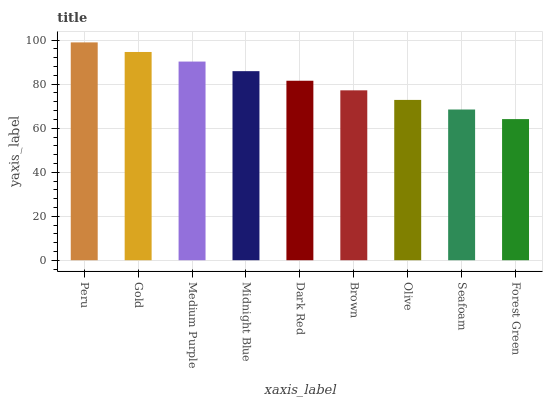Is Forest Green the minimum?
Answer yes or no. Yes. Is Peru the maximum?
Answer yes or no. Yes. Is Gold the minimum?
Answer yes or no. No. Is Gold the maximum?
Answer yes or no. No. Is Peru greater than Gold?
Answer yes or no. Yes. Is Gold less than Peru?
Answer yes or no. Yes. Is Gold greater than Peru?
Answer yes or no. No. Is Peru less than Gold?
Answer yes or no. No. Is Dark Red the high median?
Answer yes or no. Yes. Is Dark Red the low median?
Answer yes or no. Yes. Is Olive the high median?
Answer yes or no. No. Is Peru the low median?
Answer yes or no. No. 